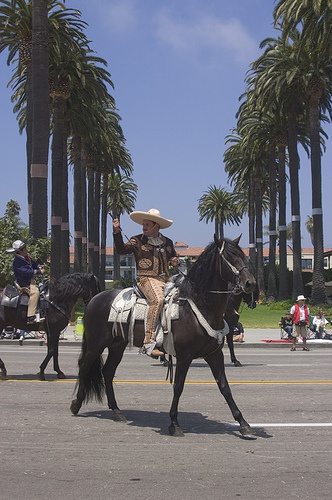Describe the objects in this image and their specific colors. I can see horse in black, gray, darkgray, and lightgray tones, people in black and gray tones, horse in black and gray tones, people in black, gray, and darkgray tones, and horse in black, gray, darkgray, and darkgreen tones in this image. 